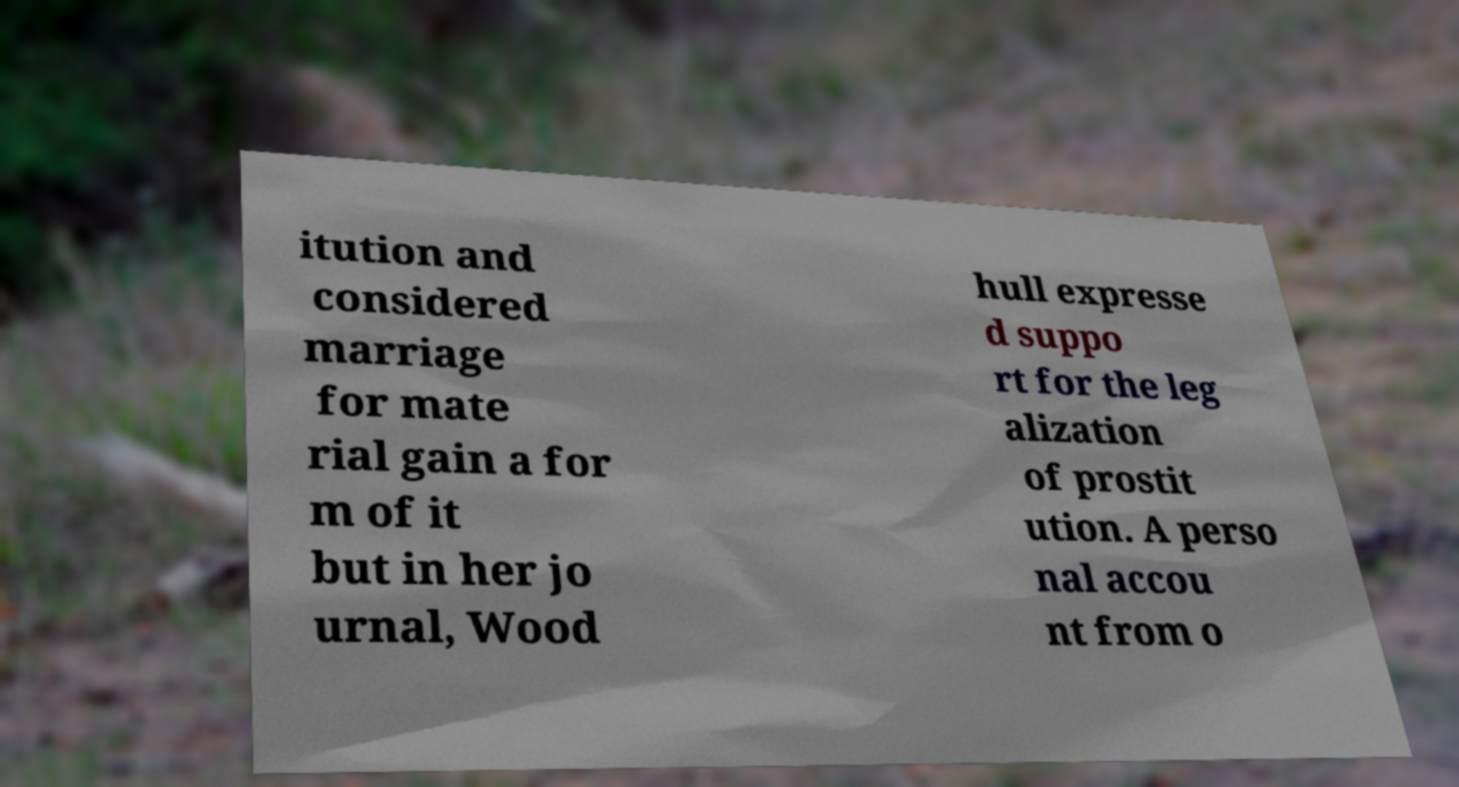Please identify and transcribe the text found in this image. itution and considered marriage for mate rial gain a for m of it but in her jo urnal, Wood hull expresse d suppo rt for the leg alization of prostit ution. A perso nal accou nt from o 